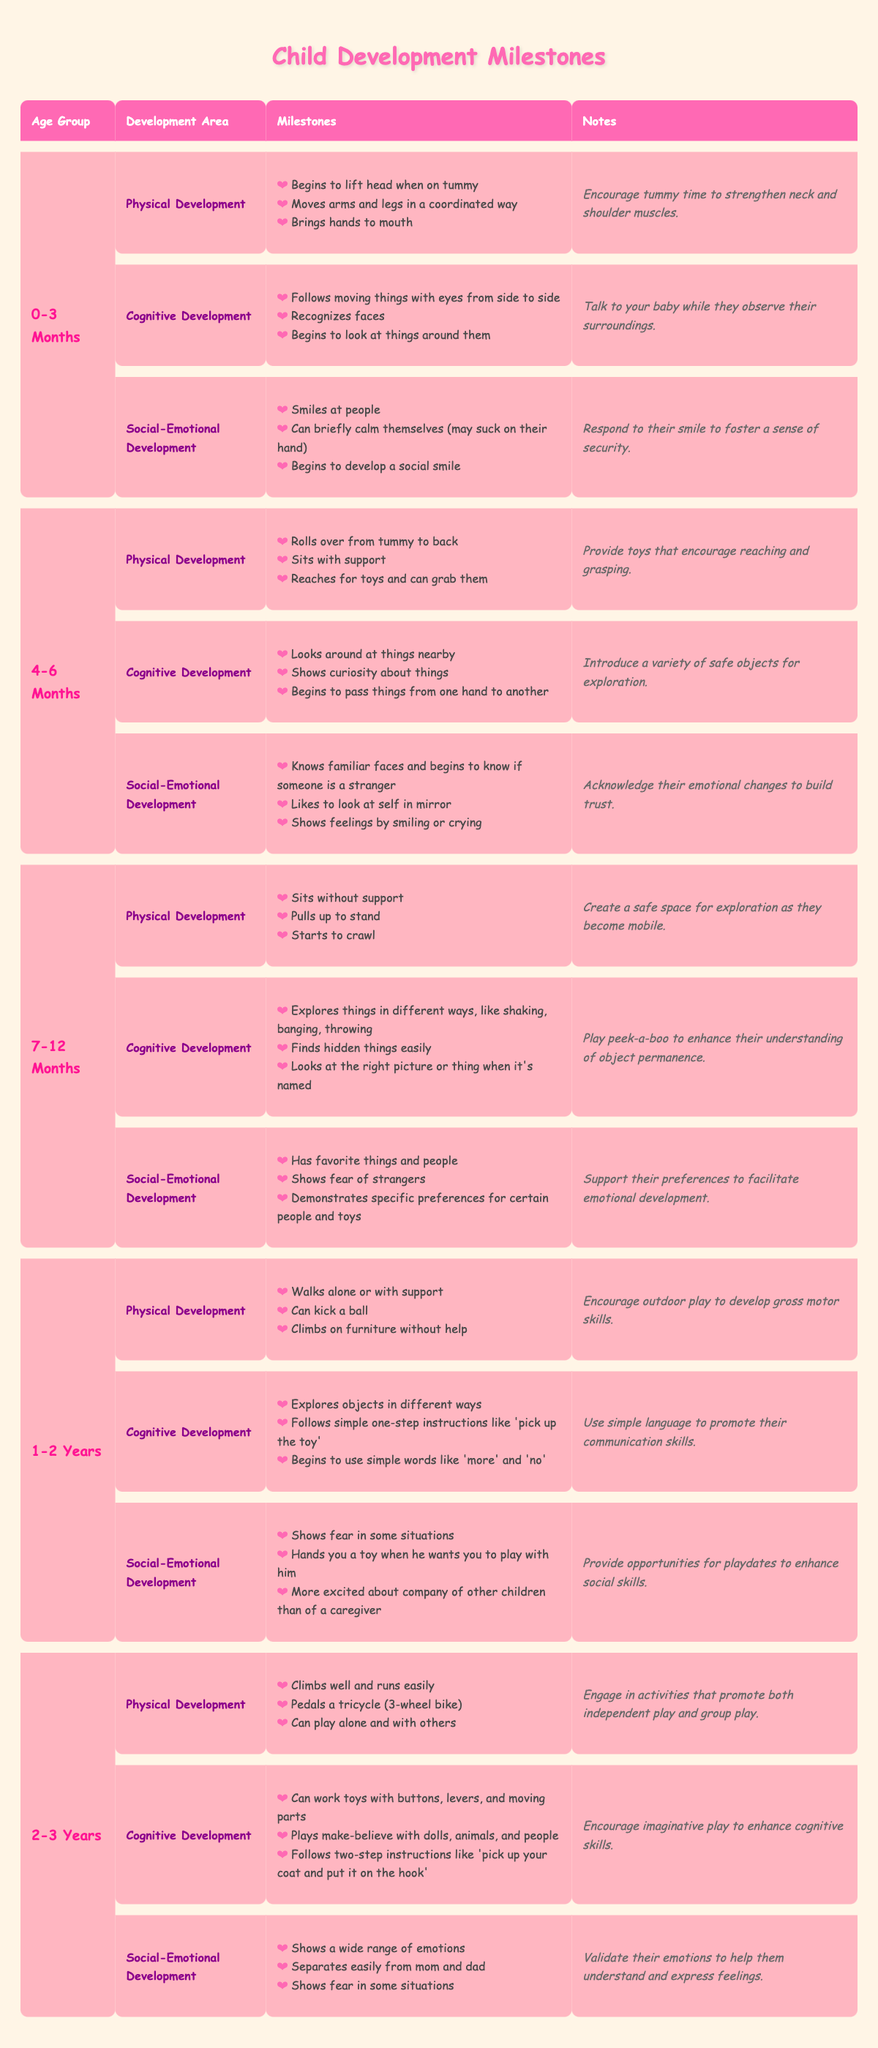What milestones should I expect for my baby between 4-6 months in cognitive development? The table states the cognitive milestones for the 4-6 months age group, which include: "Looks around at things nearby", "Shows curiosity about things", and "Begins to pass things from one hand to another".
Answer: Looks around at things nearby, shows curiosity about things, begins to pass things from one hand to another Does a child in the 1-2 years age group show excitement about being with other children? Yes, the table indicates that children in this age group are "More excited about company of other children than of a caregiver".
Answer: Yes How many milestones are listed for social-emotional development in the 0-3 months age group? The table lists three milestones for social-emotional development in the 0-3 months age group: "Smiles at people", "Can briefly calm themselves (may suck on their hand)", and "Begins to develop a social smile".
Answer: Three milestones Which age group has a developmental milestone of "Can kick a ball"? The developmental milestone of "Can kick a ball" is listed under the 1-2 years age group.
Answer: 1-2 years For a child aged 2-3 years, what are the cognitive development milestones? The cognitive development milestones for the 2-3 years age group are: "Can work toys with buttons, levers, and moving parts", "Plays make-believe with dolls, animals, and people", and "Follows two-step instructions like 'pick up your coat and put it on the hook'".
Answer: Can work toys with buttons, plays make-believe, follows two-step instructions What is the total number of physical development milestones for the age groups from 0-3 months through 2-3 years? The count of physical development milestones is as follows: 3 (0-3 months) + 3 (4-6 months) + 3 (7-12 months) + 3 (1-2 years) + 3 (2-3 years) = 15 total milestones.
Answer: 15 Is it true that children aged 7-12 months have specific preferences for toys? Yes, the table states that children in this age group "Demonstrates specific preferences for certain people and toys".
Answer: Yes What notes are provided for physical development at age 1-2 years? The table states the notes for physical development in the 1-2 years age group are: "Encourage outdoor play to develop gross motor skills."
Answer: Encourage outdoor play to develop gross motor skills 